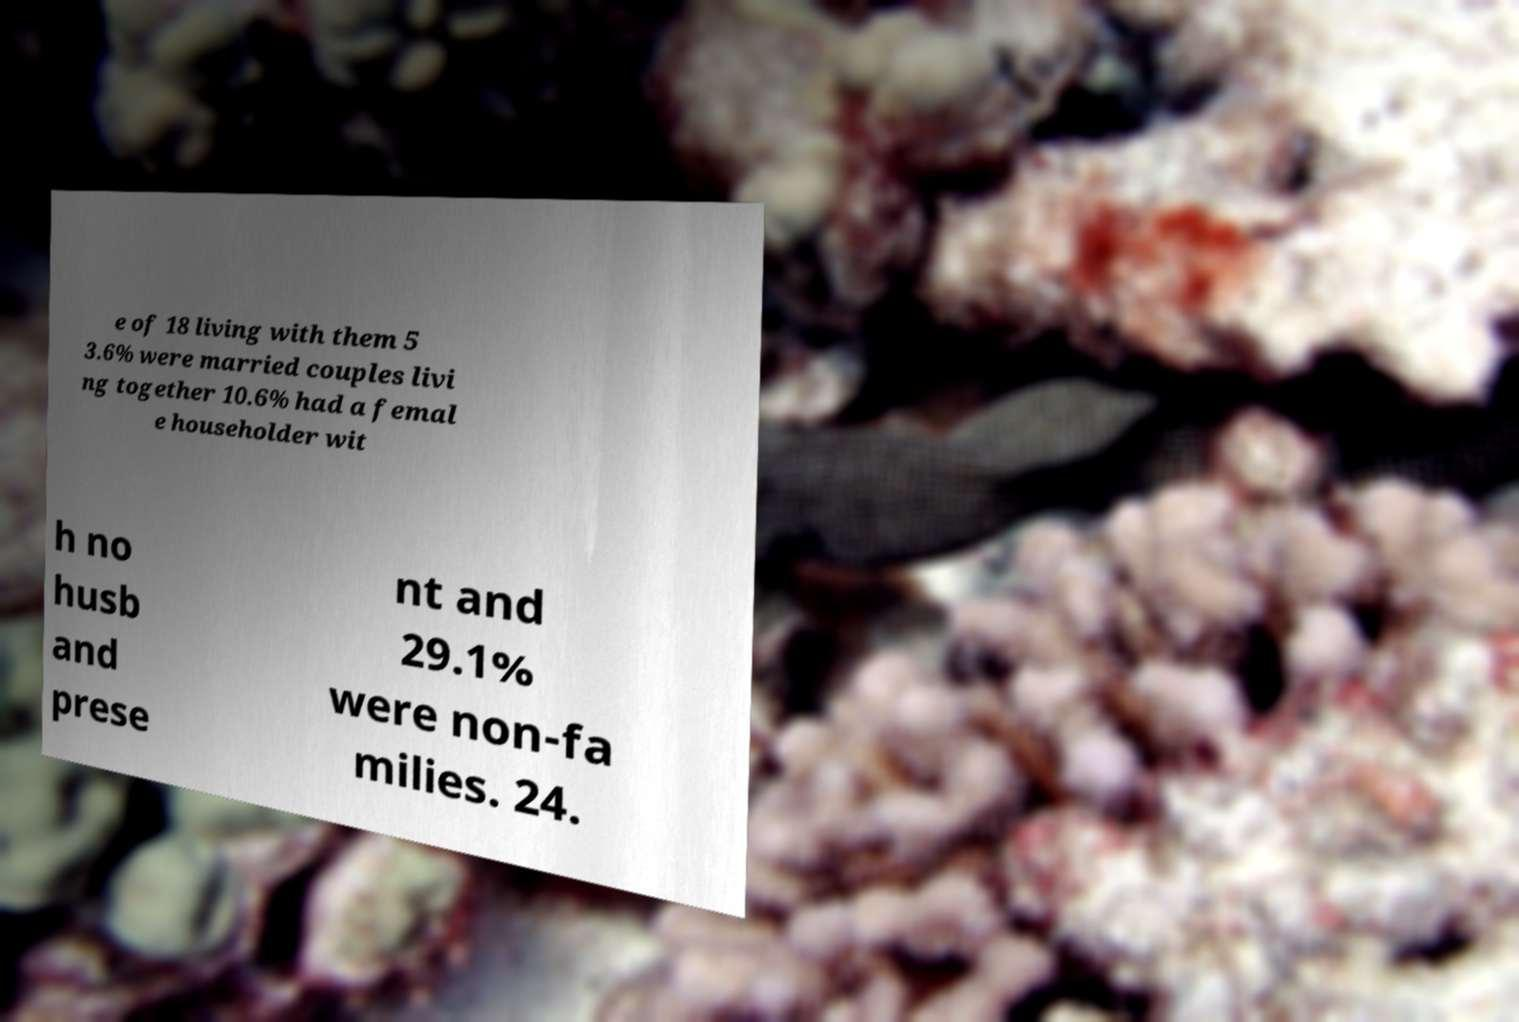Please read and relay the text visible in this image. What does it say? e of 18 living with them 5 3.6% were married couples livi ng together 10.6% had a femal e householder wit h no husb and prese nt and 29.1% were non-fa milies. 24. 